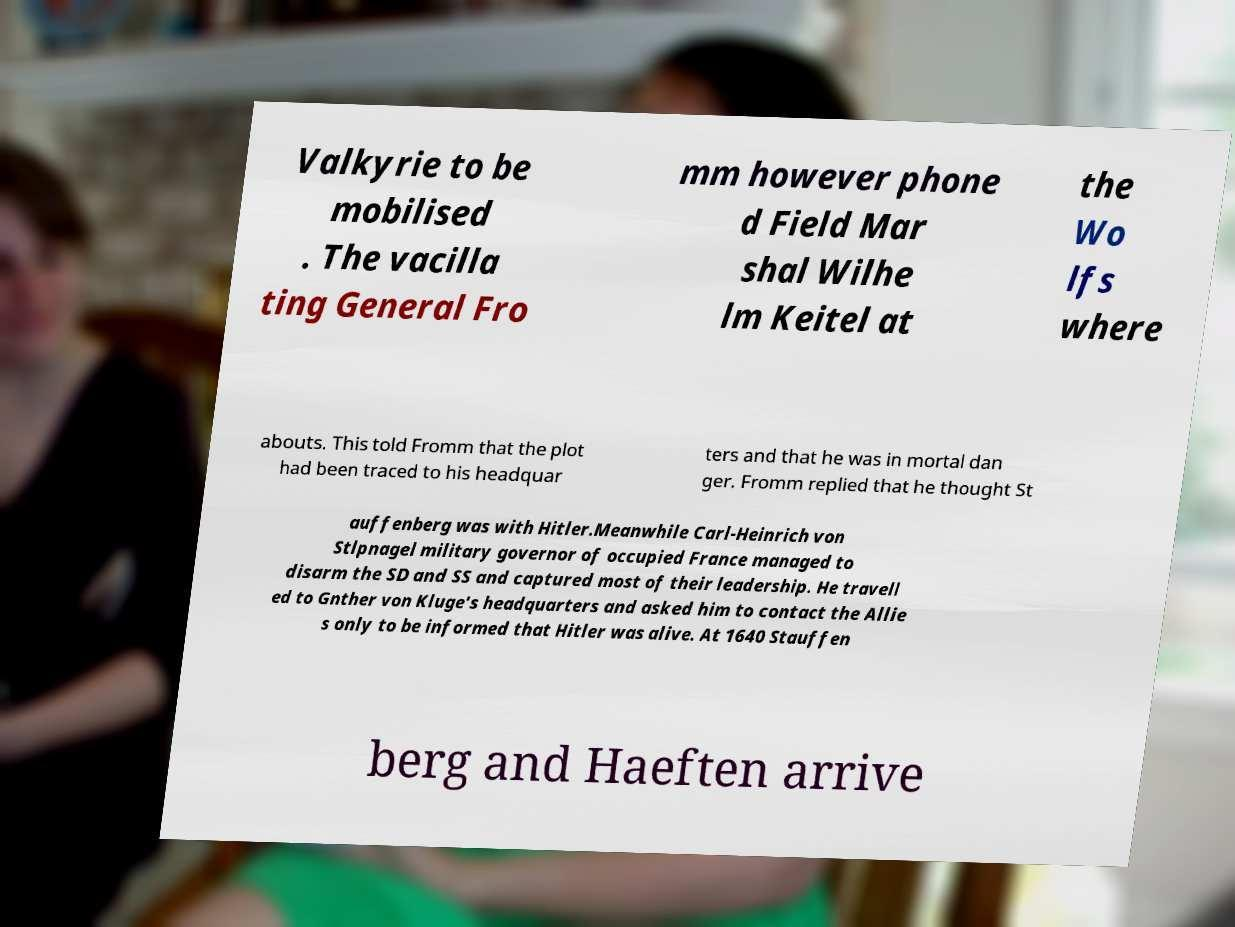Please read and relay the text visible in this image. What does it say? Valkyrie to be mobilised . The vacilla ting General Fro mm however phone d Field Mar shal Wilhe lm Keitel at the Wo lfs where abouts. This told Fromm that the plot had been traced to his headquar ters and that he was in mortal dan ger. Fromm replied that he thought St auffenberg was with Hitler.Meanwhile Carl-Heinrich von Stlpnagel military governor of occupied France managed to disarm the SD and SS and captured most of their leadership. He travell ed to Gnther von Kluge's headquarters and asked him to contact the Allie s only to be informed that Hitler was alive. At 1640 Stauffen berg and Haeften arrive 